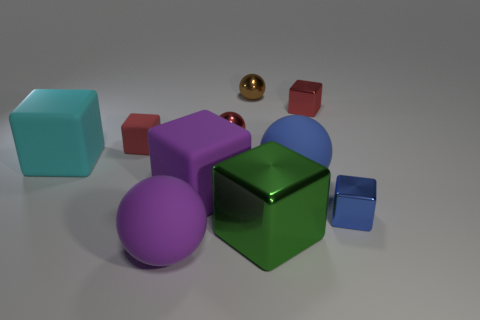Subtract all small blue cubes. How many cubes are left? 5 Subtract all green blocks. How many blocks are left? 5 Subtract all balls. How many objects are left? 6 Subtract 5 blocks. How many blocks are left? 1 Subtract all cyan things. Subtract all brown shiny objects. How many objects are left? 8 Add 5 tiny shiny objects. How many tiny shiny objects are left? 9 Add 9 red balls. How many red balls exist? 10 Subtract 0 gray cubes. How many objects are left? 10 Subtract all yellow spheres. Subtract all yellow cylinders. How many spheres are left? 4 Subtract all blue cylinders. How many red balls are left? 1 